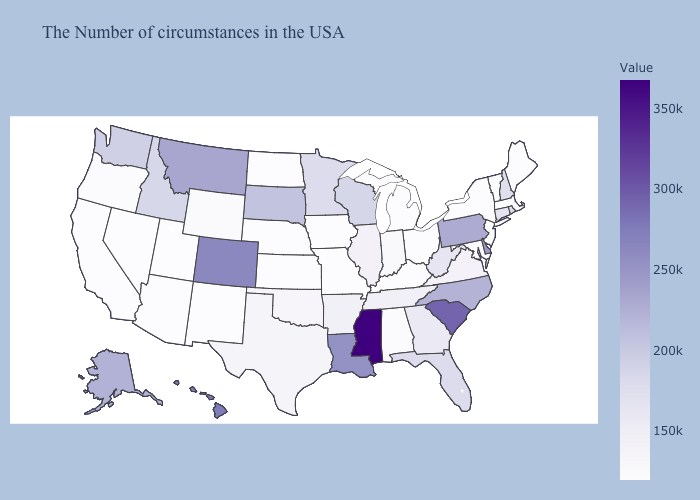Among the states that border Ohio , does Pennsylvania have the highest value?
Write a very short answer. Yes. Which states have the highest value in the USA?
Write a very short answer. Mississippi. Does South Dakota have the highest value in the MidWest?
Concise answer only. Yes. Does Missouri have a higher value than Connecticut?
Quick response, please. No. Which states hav the highest value in the Northeast?
Be succinct. Pennsylvania. Among the states that border New Mexico , which have the highest value?
Be succinct. Colorado. Among the states that border Connecticut , does Massachusetts have the lowest value?
Be succinct. Yes. Does Rhode Island have a higher value than Delaware?
Quick response, please. No. Does South Dakota have the highest value in the MidWest?
Give a very brief answer. Yes. Does Connecticut have a lower value than Indiana?
Keep it brief. No. 